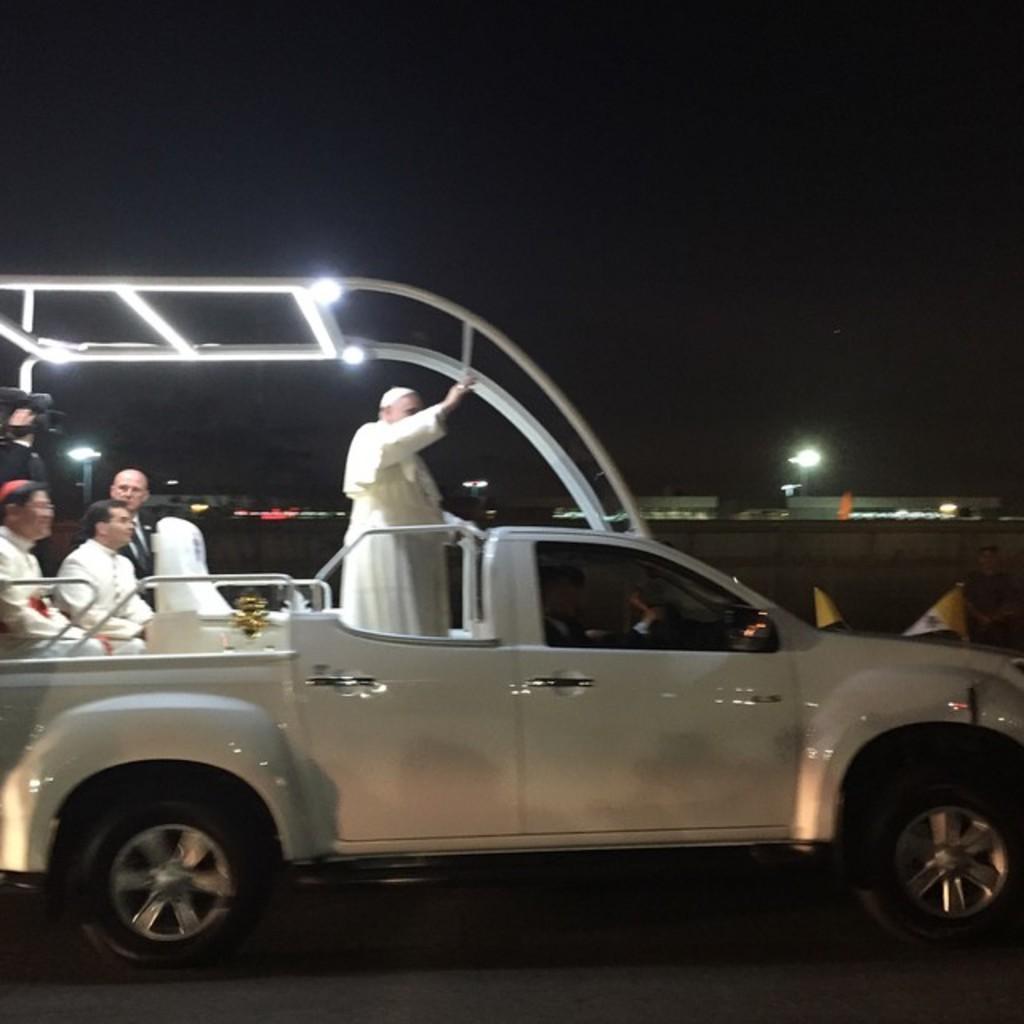In one or two sentences, can you explain what this image depicts? In this image there is one vehicle. One person is driving the vehicle and there are some people who are sitting in the vehicle on the left side of the middle of the image there is one person who is holding a camera on the left side of the image there are three persons who are sitting in a vehicle in the middle of the image there is one par person who is standing and waving his hand on the top of the vehicle there are two lights on the right side of the image there is one wall and one street light and there are some houses. 